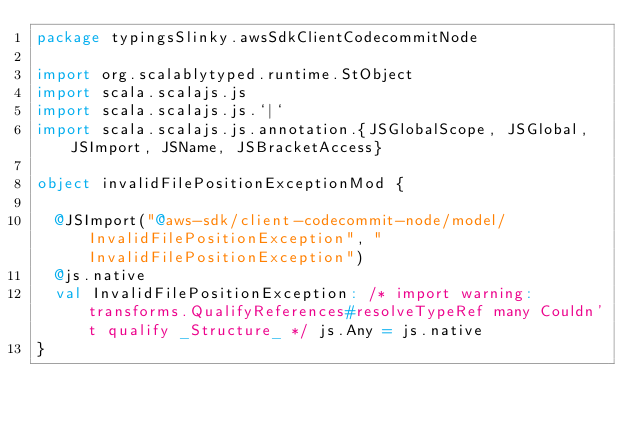<code> <loc_0><loc_0><loc_500><loc_500><_Scala_>package typingsSlinky.awsSdkClientCodecommitNode

import org.scalablytyped.runtime.StObject
import scala.scalajs.js
import scala.scalajs.js.`|`
import scala.scalajs.js.annotation.{JSGlobalScope, JSGlobal, JSImport, JSName, JSBracketAccess}

object invalidFilePositionExceptionMod {
  
  @JSImport("@aws-sdk/client-codecommit-node/model/InvalidFilePositionException", "InvalidFilePositionException")
  @js.native
  val InvalidFilePositionException: /* import warning: transforms.QualifyReferences#resolveTypeRef many Couldn't qualify _Structure_ */ js.Any = js.native
}
</code> 